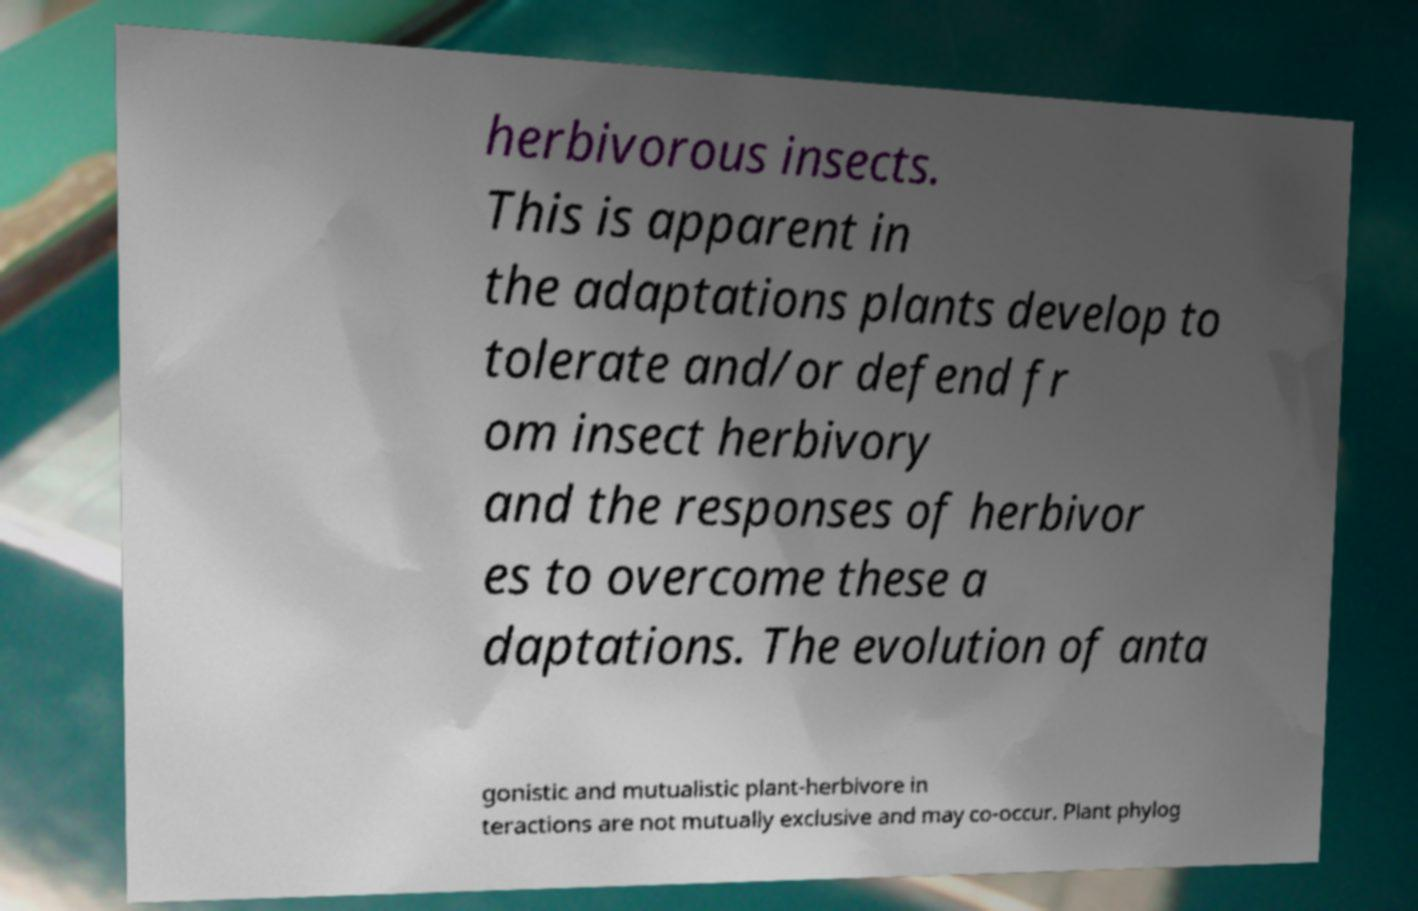What messages or text are displayed in this image? I need them in a readable, typed format. herbivorous insects. This is apparent in the adaptations plants develop to tolerate and/or defend fr om insect herbivory and the responses of herbivor es to overcome these a daptations. The evolution of anta gonistic and mutualistic plant-herbivore in teractions are not mutually exclusive and may co-occur. Plant phylog 